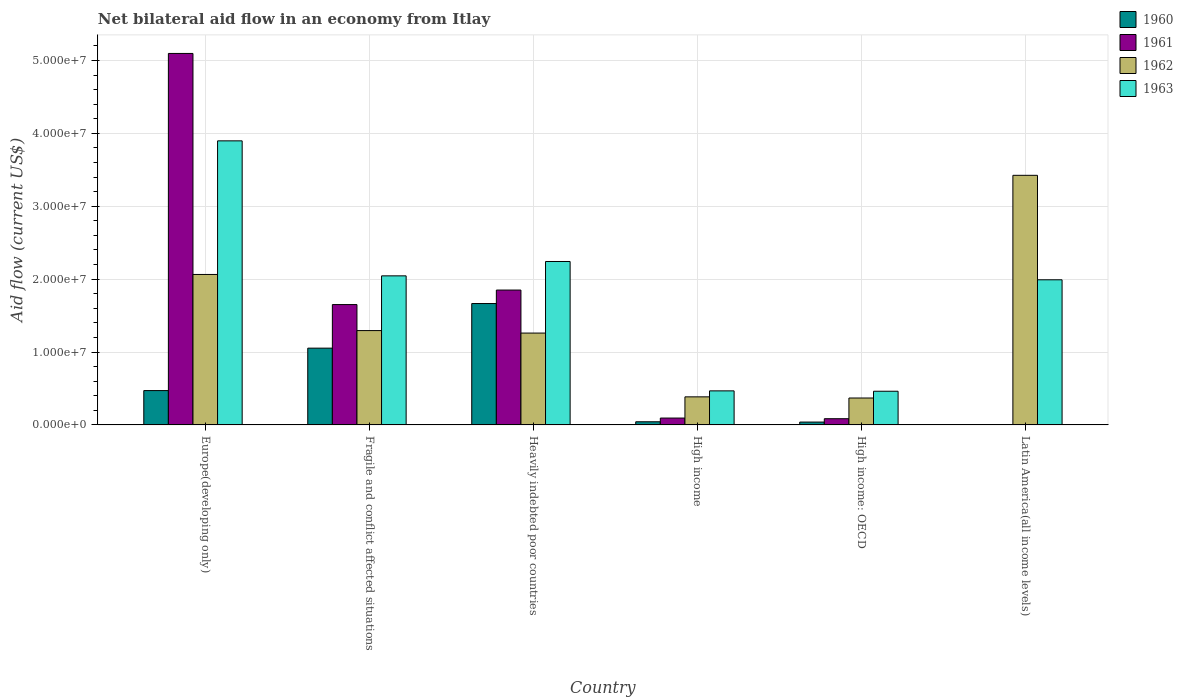How many different coloured bars are there?
Your response must be concise. 4. Are the number of bars on each tick of the X-axis equal?
Your response must be concise. No. How many bars are there on the 4th tick from the right?
Your answer should be compact. 4. What is the label of the 5th group of bars from the left?
Make the answer very short. High income: OECD. In how many cases, is the number of bars for a given country not equal to the number of legend labels?
Offer a terse response. 1. What is the net bilateral aid flow in 1963 in Latin America(all income levels)?
Your answer should be compact. 1.99e+07. Across all countries, what is the maximum net bilateral aid flow in 1962?
Give a very brief answer. 3.42e+07. Across all countries, what is the minimum net bilateral aid flow in 1963?
Provide a succinct answer. 4.62e+06. In which country was the net bilateral aid flow in 1961 maximum?
Offer a very short reply. Europe(developing only). What is the total net bilateral aid flow in 1963 in the graph?
Your response must be concise. 1.11e+08. What is the difference between the net bilateral aid flow in 1960 in Fragile and conflict affected situations and that in High income?
Provide a succinct answer. 1.01e+07. What is the difference between the net bilateral aid flow in 1962 in Europe(developing only) and the net bilateral aid flow in 1961 in Latin America(all income levels)?
Offer a terse response. 2.06e+07. What is the average net bilateral aid flow in 1963 per country?
Offer a very short reply. 1.85e+07. What is the difference between the net bilateral aid flow of/in 1962 and net bilateral aid flow of/in 1963 in Europe(developing only)?
Keep it short and to the point. -1.83e+07. In how many countries, is the net bilateral aid flow in 1962 greater than 14000000 US$?
Offer a very short reply. 2. What is the ratio of the net bilateral aid flow in 1963 in Europe(developing only) to that in Fragile and conflict affected situations?
Offer a terse response. 1.91. What is the difference between the highest and the second highest net bilateral aid flow in 1963?
Your answer should be very brief. 1.66e+07. What is the difference between the highest and the lowest net bilateral aid flow in 1960?
Offer a very short reply. 1.66e+07. Is the sum of the net bilateral aid flow in 1962 in High income and Latin America(all income levels) greater than the maximum net bilateral aid flow in 1961 across all countries?
Your answer should be compact. No. Is it the case that in every country, the sum of the net bilateral aid flow in 1962 and net bilateral aid flow in 1961 is greater than the sum of net bilateral aid flow in 1963 and net bilateral aid flow in 1960?
Offer a terse response. No. Is it the case that in every country, the sum of the net bilateral aid flow in 1961 and net bilateral aid flow in 1963 is greater than the net bilateral aid flow in 1960?
Offer a terse response. Yes. Are all the bars in the graph horizontal?
Your response must be concise. No. Are the values on the major ticks of Y-axis written in scientific E-notation?
Offer a very short reply. Yes. Does the graph contain any zero values?
Keep it short and to the point. Yes. Where does the legend appear in the graph?
Ensure brevity in your answer.  Top right. How many legend labels are there?
Make the answer very short. 4. What is the title of the graph?
Your response must be concise. Net bilateral aid flow in an economy from Itlay. What is the label or title of the Y-axis?
Provide a short and direct response. Aid flow (current US$). What is the Aid flow (current US$) in 1960 in Europe(developing only)?
Offer a very short reply. 4.71e+06. What is the Aid flow (current US$) in 1961 in Europe(developing only)?
Give a very brief answer. 5.10e+07. What is the Aid flow (current US$) of 1962 in Europe(developing only)?
Provide a succinct answer. 2.06e+07. What is the Aid flow (current US$) of 1963 in Europe(developing only)?
Offer a very short reply. 3.90e+07. What is the Aid flow (current US$) of 1960 in Fragile and conflict affected situations?
Make the answer very short. 1.05e+07. What is the Aid flow (current US$) in 1961 in Fragile and conflict affected situations?
Make the answer very short. 1.65e+07. What is the Aid flow (current US$) of 1962 in Fragile and conflict affected situations?
Keep it short and to the point. 1.29e+07. What is the Aid flow (current US$) of 1963 in Fragile and conflict affected situations?
Offer a very short reply. 2.04e+07. What is the Aid flow (current US$) of 1960 in Heavily indebted poor countries?
Provide a short and direct response. 1.66e+07. What is the Aid flow (current US$) of 1961 in Heavily indebted poor countries?
Keep it short and to the point. 1.85e+07. What is the Aid flow (current US$) of 1962 in Heavily indebted poor countries?
Offer a very short reply. 1.26e+07. What is the Aid flow (current US$) of 1963 in Heavily indebted poor countries?
Make the answer very short. 2.24e+07. What is the Aid flow (current US$) of 1961 in High income?
Ensure brevity in your answer.  9.40e+05. What is the Aid flow (current US$) of 1962 in High income?
Your answer should be very brief. 3.85e+06. What is the Aid flow (current US$) in 1963 in High income?
Ensure brevity in your answer.  4.67e+06. What is the Aid flow (current US$) in 1960 in High income: OECD?
Your response must be concise. 3.90e+05. What is the Aid flow (current US$) in 1961 in High income: OECD?
Your response must be concise. 8.50e+05. What is the Aid flow (current US$) in 1962 in High income: OECD?
Offer a very short reply. 3.69e+06. What is the Aid flow (current US$) of 1963 in High income: OECD?
Your answer should be compact. 4.62e+06. What is the Aid flow (current US$) in 1961 in Latin America(all income levels)?
Offer a terse response. 0. What is the Aid flow (current US$) of 1962 in Latin America(all income levels)?
Your answer should be very brief. 3.42e+07. What is the Aid flow (current US$) in 1963 in Latin America(all income levels)?
Provide a succinct answer. 1.99e+07. Across all countries, what is the maximum Aid flow (current US$) in 1960?
Offer a very short reply. 1.66e+07. Across all countries, what is the maximum Aid flow (current US$) in 1961?
Your response must be concise. 5.10e+07. Across all countries, what is the maximum Aid flow (current US$) of 1962?
Your response must be concise. 3.42e+07. Across all countries, what is the maximum Aid flow (current US$) of 1963?
Make the answer very short. 3.90e+07. Across all countries, what is the minimum Aid flow (current US$) of 1961?
Keep it short and to the point. 0. Across all countries, what is the minimum Aid flow (current US$) of 1962?
Keep it short and to the point. 3.69e+06. Across all countries, what is the minimum Aid flow (current US$) in 1963?
Give a very brief answer. 4.62e+06. What is the total Aid flow (current US$) in 1960 in the graph?
Ensure brevity in your answer.  3.27e+07. What is the total Aid flow (current US$) in 1961 in the graph?
Offer a very short reply. 8.78e+07. What is the total Aid flow (current US$) in 1962 in the graph?
Make the answer very short. 8.80e+07. What is the total Aid flow (current US$) of 1963 in the graph?
Offer a terse response. 1.11e+08. What is the difference between the Aid flow (current US$) in 1960 in Europe(developing only) and that in Fragile and conflict affected situations?
Your answer should be very brief. -5.82e+06. What is the difference between the Aid flow (current US$) in 1961 in Europe(developing only) and that in Fragile and conflict affected situations?
Offer a terse response. 3.44e+07. What is the difference between the Aid flow (current US$) in 1962 in Europe(developing only) and that in Fragile and conflict affected situations?
Ensure brevity in your answer.  7.70e+06. What is the difference between the Aid flow (current US$) of 1963 in Europe(developing only) and that in Fragile and conflict affected situations?
Your response must be concise. 1.85e+07. What is the difference between the Aid flow (current US$) of 1960 in Europe(developing only) and that in Heavily indebted poor countries?
Your response must be concise. -1.19e+07. What is the difference between the Aid flow (current US$) of 1961 in Europe(developing only) and that in Heavily indebted poor countries?
Offer a terse response. 3.25e+07. What is the difference between the Aid flow (current US$) of 1962 in Europe(developing only) and that in Heavily indebted poor countries?
Provide a short and direct response. 8.04e+06. What is the difference between the Aid flow (current US$) of 1963 in Europe(developing only) and that in Heavily indebted poor countries?
Your answer should be very brief. 1.66e+07. What is the difference between the Aid flow (current US$) in 1960 in Europe(developing only) and that in High income?
Your answer should be very brief. 4.28e+06. What is the difference between the Aid flow (current US$) of 1961 in Europe(developing only) and that in High income?
Offer a very short reply. 5.00e+07. What is the difference between the Aid flow (current US$) of 1962 in Europe(developing only) and that in High income?
Your answer should be very brief. 1.68e+07. What is the difference between the Aid flow (current US$) of 1963 in Europe(developing only) and that in High income?
Keep it short and to the point. 3.43e+07. What is the difference between the Aid flow (current US$) in 1960 in Europe(developing only) and that in High income: OECD?
Provide a succinct answer. 4.32e+06. What is the difference between the Aid flow (current US$) of 1961 in Europe(developing only) and that in High income: OECD?
Keep it short and to the point. 5.01e+07. What is the difference between the Aid flow (current US$) of 1962 in Europe(developing only) and that in High income: OECD?
Make the answer very short. 1.70e+07. What is the difference between the Aid flow (current US$) in 1963 in Europe(developing only) and that in High income: OECD?
Offer a terse response. 3.44e+07. What is the difference between the Aid flow (current US$) of 1962 in Europe(developing only) and that in Latin America(all income levels)?
Your answer should be compact. -1.36e+07. What is the difference between the Aid flow (current US$) of 1963 in Europe(developing only) and that in Latin America(all income levels)?
Your response must be concise. 1.91e+07. What is the difference between the Aid flow (current US$) of 1960 in Fragile and conflict affected situations and that in Heavily indebted poor countries?
Provide a succinct answer. -6.12e+06. What is the difference between the Aid flow (current US$) in 1961 in Fragile and conflict affected situations and that in Heavily indebted poor countries?
Your response must be concise. -1.99e+06. What is the difference between the Aid flow (current US$) of 1963 in Fragile and conflict affected situations and that in Heavily indebted poor countries?
Your answer should be compact. -1.97e+06. What is the difference between the Aid flow (current US$) in 1960 in Fragile and conflict affected situations and that in High income?
Offer a terse response. 1.01e+07. What is the difference between the Aid flow (current US$) of 1961 in Fragile and conflict affected situations and that in High income?
Your response must be concise. 1.56e+07. What is the difference between the Aid flow (current US$) in 1962 in Fragile and conflict affected situations and that in High income?
Provide a short and direct response. 9.09e+06. What is the difference between the Aid flow (current US$) of 1963 in Fragile and conflict affected situations and that in High income?
Your response must be concise. 1.58e+07. What is the difference between the Aid flow (current US$) of 1960 in Fragile and conflict affected situations and that in High income: OECD?
Make the answer very short. 1.01e+07. What is the difference between the Aid flow (current US$) in 1961 in Fragile and conflict affected situations and that in High income: OECD?
Provide a succinct answer. 1.57e+07. What is the difference between the Aid flow (current US$) in 1962 in Fragile and conflict affected situations and that in High income: OECD?
Ensure brevity in your answer.  9.25e+06. What is the difference between the Aid flow (current US$) in 1963 in Fragile and conflict affected situations and that in High income: OECD?
Offer a very short reply. 1.58e+07. What is the difference between the Aid flow (current US$) of 1962 in Fragile and conflict affected situations and that in Latin America(all income levels)?
Offer a terse response. -2.13e+07. What is the difference between the Aid flow (current US$) in 1963 in Fragile and conflict affected situations and that in Latin America(all income levels)?
Keep it short and to the point. 5.40e+05. What is the difference between the Aid flow (current US$) of 1960 in Heavily indebted poor countries and that in High income?
Ensure brevity in your answer.  1.62e+07. What is the difference between the Aid flow (current US$) in 1961 in Heavily indebted poor countries and that in High income?
Your answer should be very brief. 1.76e+07. What is the difference between the Aid flow (current US$) of 1962 in Heavily indebted poor countries and that in High income?
Keep it short and to the point. 8.75e+06. What is the difference between the Aid flow (current US$) of 1963 in Heavily indebted poor countries and that in High income?
Offer a terse response. 1.78e+07. What is the difference between the Aid flow (current US$) in 1960 in Heavily indebted poor countries and that in High income: OECD?
Your response must be concise. 1.63e+07. What is the difference between the Aid flow (current US$) in 1961 in Heavily indebted poor countries and that in High income: OECD?
Provide a short and direct response. 1.76e+07. What is the difference between the Aid flow (current US$) of 1962 in Heavily indebted poor countries and that in High income: OECD?
Provide a succinct answer. 8.91e+06. What is the difference between the Aid flow (current US$) in 1963 in Heavily indebted poor countries and that in High income: OECD?
Provide a succinct answer. 1.78e+07. What is the difference between the Aid flow (current US$) of 1962 in Heavily indebted poor countries and that in Latin America(all income levels)?
Keep it short and to the point. -2.16e+07. What is the difference between the Aid flow (current US$) in 1963 in Heavily indebted poor countries and that in Latin America(all income levels)?
Provide a succinct answer. 2.51e+06. What is the difference between the Aid flow (current US$) of 1961 in High income and that in High income: OECD?
Your answer should be compact. 9.00e+04. What is the difference between the Aid flow (current US$) of 1962 in High income and that in High income: OECD?
Give a very brief answer. 1.60e+05. What is the difference between the Aid flow (current US$) of 1962 in High income and that in Latin America(all income levels)?
Keep it short and to the point. -3.04e+07. What is the difference between the Aid flow (current US$) of 1963 in High income and that in Latin America(all income levels)?
Keep it short and to the point. -1.52e+07. What is the difference between the Aid flow (current US$) in 1962 in High income: OECD and that in Latin America(all income levels)?
Make the answer very short. -3.06e+07. What is the difference between the Aid flow (current US$) of 1963 in High income: OECD and that in Latin America(all income levels)?
Provide a short and direct response. -1.53e+07. What is the difference between the Aid flow (current US$) of 1960 in Europe(developing only) and the Aid flow (current US$) of 1961 in Fragile and conflict affected situations?
Your answer should be compact. -1.18e+07. What is the difference between the Aid flow (current US$) of 1960 in Europe(developing only) and the Aid flow (current US$) of 1962 in Fragile and conflict affected situations?
Offer a very short reply. -8.23e+06. What is the difference between the Aid flow (current US$) in 1960 in Europe(developing only) and the Aid flow (current US$) in 1963 in Fragile and conflict affected situations?
Make the answer very short. -1.57e+07. What is the difference between the Aid flow (current US$) in 1961 in Europe(developing only) and the Aid flow (current US$) in 1962 in Fragile and conflict affected situations?
Provide a succinct answer. 3.80e+07. What is the difference between the Aid flow (current US$) in 1961 in Europe(developing only) and the Aid flow (current US$) in 1963 in Fragile and conflict affected situations?
Your answer should be compact. 3.05e+07. What is the difference between the Aid flow (current US$) in 1960 in Europe(developing only) and the Aid flow (current US$) in 1961 in Heavily indebted poor countries?
Your answer should be compact. -1.38e+07. What is the difference between the Aid flow (current US$) of 1960 in Europe(developing only) and the Aid flow (current US$) of 1962 in Heavily indebted poor countries?
Your answer should be compact. -7.89e+06. What is the difference between the Aid flow (current US$) in 1960 in Europe(developing only) and the Aid flow (current US$) in 1963 in Heavily indebted poor countries?
Your answer should be compact. -1.77e+07. What is the difference between the Aid flow (current US$) in 1961 in Europe(developing only) and the Aid flow (current US$) in 1962 in Heavily indebted poor countries?
Offer a terse response. 3.84e+07. What is the difference between the Aid flow (current US$) in 1961 in Europe(developing only) and the Aid flow (current US$) in 1963 in Heavily indebted poor countries?
Your answer should be compact. 2.85e+07. What is the difference between the Aid flow (current US$) in 1962 in Europe(developing only) and the Aid flow (current US$) in 1963 in Heavily indebted poor countries?
Your answer should be very brief. -1.78e+06. What is the difference between the Aid flow (current US$) of 1960 in Europe(developing only) and the Aid flow (current US$) of 1961 in High income?
Offer a terse response. 3.77e+06. What is the difference between the Aid flow (current US$) of 1960 in Europe(developing only) and the Aid flow (current US$) of 1962 in High income?
Offer a very short reply. 8.60e+05. What is the difference between the Aid flow (current US$) in 1960 in Europe(developing only) and the Aid flow (current US$) in 1963 in High income?
Keep it short and to the point. 4.00e+04. What is the difference between the Aid flow (current US$) of 1961 in Europe(developing only) and the Aid flow (current US$) of 1962 in High income?
Your answer should be compact. 4.71e+07. What is the difference between the Aid flow (current US$) of 1961 in Europe(developing only) and the Aid flow (current US$) of 1963 in High income?
Provide a succinct answer. 4.63e+07. What is the difference between the Aid flow (current US$) of 1962 in Europe(developing only) and the Aid flow (current US$) of 1963 in High income?
Provide a short and direct response. 1.60e+07. What is the difference between the Aid flow (current US$) of 1960 in Europe(developing only) and the Aid flow (current US$) of 1961 in High income: OECD?
Make the answer very short. 3.86e+06. What is the difference between the Aid flow (current US$) of 1960 in Europe(developing only) and the Aid flow (current US$) of 1962 in High income: OECD?
Your answer should be very brief. 1.02e+06. What is the difference between the Aid flow (current US$) in 1960 in Europe(developing only) and the Aid flow (current US$) in 1963 in High income: OECD?
Make the answer very short. 9.00e+04. What is the difference between the Aid flow (current US$) of 1961 in Europe(developing only) and the Aid flow (current US$) of 1962 in High income: OECD?
Your answer should be very brief. 4.73e+07. What is the difference between the Aid flow (current US$) of 1961 in Europe(developing only) and the Aid flow (current US$) of 1963 in High income: OECD?
Give a very brief answer. 4.63e+07. What is the difference between the Aid flow (current US$) in 1962 in Europe(developing only) and the Aid flow (current US$) in 1963 in High income: OECD?
Your answer should be compact. 1.60e+07. What is the difference between the Aid flow (current US$) in 1960 in Europe(developing only) and the Aid flow (current US$) in 1962 in Latin America(all income levels)?
Make the answer very short. -2.95e+07. What is the difference between the Aid flow (current US$) in 1960 in Europe(developing only) and the Aid flow (current US$) in 1963 in Latin America(all income levels)?
Your response must be concise. -1.52e+07. What is the difference between the Aid flow (current US$) in 1961 in Europe(developing only) and the Aid flow (current US$) in 1962 in Latin America(all income levels)?
Provide a short and direct response. 1.67e+07. What is the difference between the Aid flow (current US$) of 1961 in Europe(developing only) and the Aid flow (current US$) of 1963 in Latin America(all income levels)?
Give a very brief answer. 3.10e+07. What is the difference between the Aid flow (current US$) of 1962 in Europe(developing only) and the Aid flow (current US$) of 1963 in Latin America(all income levels)?
Offer a very short reply. 7.30e+05. What is the difference between the Aid flow (current US$) in 1960 in Fragile and conflict affected situations and the Aid flow (current US$) in 1961 in Heavily indebted poor countries?
Your response must be concise. -7.97e+06. What is the difference between the Aid flow (current US$) in 1960 in Fragile and conflict affected situations and the Aid flow (current US$) in 1962 in Heavily indebted poor countries?
Your response must be concise. -2.07e+06. What is the difference between the Aid flow (current US$) of 1960 in Fragile and conflict affected situations and the Aid flow (current US$) of 1963 in Heavily indebted poor countries?
Make the answer very short. -1.19e+07. What is the difference between the Aid flow (current US$) of 1961 in Fragile and conflict affected situations and the Aid flow (current US$) of 1962 in Heavily indebted poor countries?
Keep it short and to the point. 3.91e+06. What is the difference between the Aid flow (current US$) of 1961 in Fragile and conflict affected situations and the Aid flow (current US$) of 1963 in Heavily indebted poor countries?
Offer a terse response. -5.91e+06. What is the difference between the Aid flow (current US$) in 1962 in Fragile and conflict affected situations and the Aid flow (current US$) in 1963 in Heavily indebted poor countries?
Ensure brevity in your answer.  -9.48e+06. What is the difference between the Aid flow (current US$) in 1960 in Fragile and conflict affected situations and the Aid flow (current US$) in 1961 in High income?
Provide a succinct answer. 9.59e+06. What is the difference between the Aid flow (current US$) in 1960 in Fragile and conflict affected situations and the Aid flow (current US$) in 1962 in High income?
Ensure brevity in your answer.  6.68e+06. What is the difference between the Aid flow (current US$) of 1960 in Fragile and conflict affected situations and the Aid flow (current US$) of 1963 in High income?
Your response must be concise. 5.86e+06. What is the difference between the Aid flow (current US$) of 1961 in Fragile and conflict affected situations and the Aid flow (current US$) of 1962 in High income?
Your answer should be very brief. 1.27e+07. What is the difference between the Aid flow (current US$) in 1961 in Fragile and conflict affected situations and the Aid flow (current US$) in 1963 in High income?
Ensure brevity in your answer.  1.18e+07. What is the difference between the Aid flow (current US$) in 1962 in Fragile and conflict affected situations and the Aid flow (current US$) in 1963 in High income?
Your response must be concise. 8.27e+06. What is the difference between the Aid flow (current US$) of 1960 in Fragile and conflict affected situations and the Aid flow (current US$) of 1961 in High income: OECD?
Ensure brevity in your answer.  9.68e+06. What is the difference between the Aid flow (current US$) in 1960 in Fragile and conflict affected situations and the Aid flow (current US$) in 1962 in High income: OECD?
Provide a succinct answer. 6.84e+06. What is the difference between the Aid flow (current US$) of 1960 in Fragile and conflict affected situations and the Aid flow (current US$) of 1963 in High income: OECD?
Ensure brevity in your answer.  5.91e+06. What is the difference between the Aid flow (current US$) of 1961 in Fragile and conflict affected situations and the Aid flow (current US$) of 1962 in High income: OECD?
Your answer should be very brief. 1.28e+07. What is the difference between the Aid flow (current US$) of 1961 in Fragile and conflict affected situations and the Aid flow (current US$) of 1963 in High income: OECD?
Ensure brevity in your answer.  1.19e+07. What is the difference between the Aid flow (current US$) in 1962 in Fragile and conflict affected situations and the Aid flow (current US$) in 1963 in High income: OECD?
Give a very brief answer. 8.32e+06. What is the difference between the Aid flow (current US$) in 1960 in Fragile and conflict affected situations and the Aid flow (current US$) in 1962 in Latin America(all income levels)?
Your answer should be very brief. -2.37e+07. What is the difference between the Aid flow (current US$) in 1960 in Fragile and conflict affected situations and the Aid flow (current US$) in 1963 in Latin America(all income levels)?
Provide a succinct answer. -9.38e+06. What is the difference between the Aid flow (current US$) in 1961 in Fragile and conflict affected situations and the Aid flow (current US$) in 1962 in Latin America(all income levels)?
Provide a succinct answer. -1.77e+07. What is the difference between the Aid flow (current US$) in 1961 in Fragile and conflict affected situations and the Aid flow (current US$) in 1963 in Latin America(all income levels)?
Your answer should be very brief. -3.40e+06. What is the difference between the Aid flow (current US$) of 1962 in Fragile and conflict affected situations and the Aid flow (current US$) of 1963 in Latin America(all income levels)?
Keep it short and to the point. -6.97e+06. What is the difference between the Aid flow (current US$) of 1960 in Heavily indebted poor countries and the Aid flow (current US$) of 1961 in High income?
Your response must be concise. 1.57e+07. What is the difference between the Aid flow (current US$) in 1960 in Heavily indebted poor countries and the Aid flow (current US$) in 1962 in High income?
Your answer should be compact. 1.28e+07. What is the difference between the Aid flow (current US$) in 1960 in Heavily indebted poor countries and the Aid flow (current US$) in 1963 in High income?
Keep it short and to the point. 1.20e+07. What is the difference between the Aid flow (current US$) in 1961 in Heavily indebted poor countries and the Aid flow (current US$) in 1962 in High income?
Give a very brief answer. 1.46e+07. What is the difference between the Aid flow (current US$) of 1961 in Heavily indebted poor countries and the Aid flow (current US$) of 1963 in High income?
Offer a terse response. 1.38e+07. What is the difference between the Aid flow (current US$) in 1962 in Heavily indebted poor countries and the Aid flow (current US$) in 1963 in High income?
Provide a succinct answer. 7.93e+06. What is the difference between the Aid flow (current US$) in 1960 in Heavily indebted poor countries and the Aid flow (current US$) in 1961 in High income: OECD?
Give a very brief answer. 1.58e+07. What is the difference between the Aid flow (current US$) in 1960 in Heavily indebted poor countries and the Aid flow (current US$) in 1962 in High income: OECD?
Offer a very short reply. 1.30e+07. What is the difference between the Aid flow (current US$) in 1960 in Heavily indebted poor countries and the Aid flow (current US$) in 1963 in High income: OECD?
Your response must be concise. 1.20e+07. What is the difference between the Aid flow (current US$) of 1961 in Heavily indebted poor countries and the Aid flow (current US$) of 1962 in High income: OECD?
Offer a terse response. 1.48e+07. What is the difference between the Aid flow (current US$) of 1961 in Heavily indebted poor countries and the Aid flow (current US$) of 1963 in High income: OECD?
Ensure brevity in your answer.  1.39e+07. What is the difference between the Aid flow (current US$) of 1962 in Heavily indebted poor countries and the Aid flow (current US$) of 1963 in High income: OECD?
Your response must be concise. 7.98e+06. What is the difference between the Aid flow (current US$) of 1960 in Heavily indebted poor countries and the Aid flow (current US$) of 1962 in Latin America(all income levels)?
Your answer should be very brief. -1.76e+07. What is the difference between the Aid flow (current US$) in 1960 in Heavily indebted poor countries and the Aid flow (current US$) in 1963 in Latin America(all income levels)?
Keep it short and to the point. -3.26e+06. What is the difference between the Aid flow (current US$) of 1961 in Heavily indebted poor countries and the Aid flow (current US$) of 1962 in Latin America(all income levels)?
Your answer should be very brief. -1.57e+07. What is the difference between the Aid flow (current US$) of 1961 in Heavily indebted poor countries and the Aid flow (current US$) of 1963 in Latin America(all income levels)?
Provide a short and direct response. -1.41e+06. What is the difference between the Aid flow (current US$) in 1962 in Heavily indebted poor countries and the Aid flow (current US$) in 1963 in Latin America(all income levels)?
Offer a terse response. -7.31e+06. What is the difference between the Aid flow (current US$) of 1960 in High income and the Aid flow (current US$) of 1961 in High income: OECD?
Give a very brief answer. -4.20e+05. What is the difference between the Aid flow (current US$) of 1960 in High income and the Aid flow (current US$) of 1962 in High income: OECD?
Your answer should be compact. -3.26e+06. What is the difference between the Aid flow (current US$) of 1960 in High income and the Aid flow (current US$) of 1963 in High income: OECD?
Ensure brevity in your answer.  -4.19e+06. What is the difference between the Aid flow (current US$) in 1961 in High income and the Aid flow (current US$) in 1962 in High income: OECD?
Give a very brief answer. -2.75e+06. What is the difference between the Aid flow (current US$) in 1961 in High income and the Aid flow (current US$) in 1963 in High income: OECD?
Give a very brief answer. -3.68e+06. What is the difference between the Aid flow (current US$) of 1962 in High income and the Aid flow (current US$) of 1963 in High income: OECD?
Your response must be concise. -7.70e+05. What is the difference between the Aid flow (current US$) in 1960 in High income and the Aid flow (current US$) in 1962 in Latin America(all income levels)?
Provide a short and direct response. -3.38e+07. What is the difference between the Aid flow (current US$) of 1960 in High income and the Aid flow (current US$) of 1963 in Latin America(all income levels)?
Your answer should be very brief. -1.95e+07. What is the difference between the Aid flow (current US$) in 1961 in High income and the Aid flow (current US$) in 1962 in Latin America(all income levels)?
Keep it short and to the point. -3.33e+07. What is the difference between the Aid flow (current US$) in 1961 in High income and the Aid flow (current US$) in 1963 in Latin America(all income levels)?
Give a very brief answer. -1.90e+07. What is the difference between the Aid flow (current US$) in 1962 in High income and the Aid flow (current US$) in 1963 in Latin America(all income levels)?
Offer a very short reply. -1.61e+07. What is the difference between the Aid flow (current US$) of 1960 in High income: OECD and the Aid flow (current US$) of 1962 in Latin America(all income levels)?
Offer a terse response. -3.38e+07. What is the difference between the Aid flow (current US$) in 1960 in High income: OECD and the Aid flow (current US$) in 1963 in Latin America(all income levels)?
Provide a short and direct response. -1.95e+07. What is the difference between the Aid flow (current US$) of 1961 in High income: OECD and the Aid flow (current US$) of 1962 in Latin America(all income levels)?
Provide a succinct answer. -3.34e+07. What is the difference between the Aid flow (current US$) of 1961 in High income: OECD and the Aid flow (current US$) of 1963 in Latin America(all income levels)?
Your answer should be very brief. -1.91e+07. What is the difference between the Aid flow (current US$) in 1962 in High income: OECD and the Aid flow (current US$) in 1963 in Latin America(all income levels)?
Offer a very short reply. -1.62e+07. What is the average Aid flow (current US$) of 1960 per country?
Give a very brief answer. 5.45e+06. What is the average Aid flow (current US$) in 1961 per country?
Your answer should be compact. 1.46e+07. What is the average Aid flow (current US$) of 1962 per country?
Your answer should be compact. 1.47e+07. What is the average Aid flow (current US$) of 1963 per country?
Your answer should be very brief. 1.85e+07. What is the difference between the Aid flow (current US$) of 1960 and Aid flow (current US$) of 1961 in Europe(developing only)?
Your response must be concise. -4.62e+07. What is the difference between the Aid flow (current US$) in 1960 and Aid flow (current US$) in 1962 in Europe(developing only)?
Your answer should be very brief. -1.59e+07. What is the difference between the Aid flow (current US$) in 1960 and Aid flow (current US$) in 1963 in Europe(developing only)?
Make the answer very short. -3.43e+07. What is the difference between the Aid flow (current US$) of 1961 and Aid flow (current US$) of 1962 in Europe(developing only)?
Give a very brief answer. 3.03e+07. What is the difference between the Aid flow (current US$) in 1961 and Aid flow (current US$) in 1963 in Europe(developing only)?
Your response must be concise. 1.20e+07. What is the difference between the Aid flow (current US$) in 1962 and Aid flow (current US$) in 1963 in Europe(developing only)?
Make the answer very short. -1.83e+07. What is the difference between the Aid flow (current US$) of 1960 and Aid flow (current US$) of 1961 in Fragile and conflict affected situations?
Offer a terse response. -5.98e+06. What is the difference between the Aid flow (current US$) in 1960 and Aid flow (current US$) in 1962 in Fragile and conflict affected situations?
Make the answer very short. -2.41e+06. What is the difference between the Aid flow (current US$) of 1960 and Aid flow (current US$) of 1963 in Fragile and conflict affected situations?
Your answer should be compact. -9.92e+06. What is the difference between the Aid flow (current US$) in 1961 and Aid flow (current US$) in 1962 in Fragile and conflict affected situations?
Give a very brief answer. 3.57e+06. What is the difference between the Aid flow (current US$) of 1961 and Aid flow (current US$) of 1963 in Fragile and conflict affected situations?
Offer a very short reply. -3.94e+06. What is the difference between the Aid flow (current US$) in 1962 and Aid flow (current US$) in 1963 in Fragile and conflict affected situations?
Ensure brevity in your answer.  -7.51e+06. What is the difference between the Aid flow (current US$) of 1960 and Aid flow (current US$) of 1961 in Heavily indebted poor countries?
Offer a terse response. -1.85e+06. What is the difference between the Aid flow (current US$) of 1960 and Aid flow (current US$) of 1962 in Heavily indebted poor countries?
Provide a succinct answer. 4.05e+06. What is the difference between the Aid flow (current US$) in 1960 and Aid flow (current US$) in 1963 in Heavily indebted poor countries?
Your answer should be compact. -5.77e+06. What is the difference between the Aid flow (current US$) in 1961 and Aid flow (current US$) in 1962 in Heavily indebted poor countries?
Make the answer very short. 5.90e+06. What is the difference between the Aid flow (current US$) in 1961 and Aid flow (current US$) in 1963 in Heavily indebted poor countries?
Keep it short and to the point. -3.92e+06. What is the difference between the Aid flow (current US$) in 1962 and Aid flow (current US$) in 1963 in Heavily indebted poor countries?
Ensure brevity in your answer.  -9.82e+06. What is the difference between the Aid flow (current US$) in 1960 and Aid flow (current US$) in 1961 in High income?
Provide a short and direct response. -5.10e+05. What is the difference between the Aid flow (current US$) in 1960 and Aid flow (current US$) in 1962 in High income?
Make the answer very short. -3.42e+06. What is the difference between the Aid flow (current US$) in 1960 and Aid flow (current US$) in 1963 in High income?
Your answer should be compact. -4.24e+06. What is the difference between the Aid flow (current US$) in 1961 and Aid flow (current US$) in 1962 in High income?
Ensure brevity in your answer.  -2.91e+06. What is the difference between the Aid flow (current US$) of 1961 and Aid flow (current US$) of 1963 in High income?
Your response must be concise. -3.73e+06. What is the difference between the Aid flow (current US$) of 1962 and Aid flow (current US$) of 1963 in High income?
Your answer should be compact. -8.20e+05. What is the difference between the Aid flow (current US$) of 1960 and Aid flow (current US$) of 1961 in High income: OECD?
Your answer should be compact. -4.60e+05. What is the difference between the Aid flow (current US$) of 1960 and Aid flow (current US$) of 1962 in High income: OECD?
Offer a very short reply. -3.30e+06. What is the difference between the Aid flow (current US$) of 1960 and Aid flow (current US$) of 1963 in High income: OECD?
Offer a terse response. -4.23e+06. What is the difference between the Aid flow (current US$) of 1961 and Aid flow (current US$) of 1962 in High income: OECD?
Provide a succinct answer. -2.84e+06. What is the difference between the Aid flow (current US$) of 1961 and Aid flow (current US$) of 1963 in High income: OECD?
Offer a terse response. -3.77e+06. What is the difference between the Aid flow (current US$) of 1962 and Aid flow (current US$) of 1963 in High income: OECD?
Provide a short and direct response. -9.30e+05. What is the difference between the Aid flow (current US$) in 1962 and Aid flow (current US$) in 1963 in Latin America(all income levels)?
Give a very brief answer. 1.43e+07. What is the ratio of the Aid flow (current US$) of 1960 in Europe(developing only) to that in Fragile and conflict affected situations?
Ensure brevity in your answer.  0.45. What is the ratio of the Aid flow (current US$) in 1961 in Europe(developing only) to that in Fragile and conflict affected situations?
Provide a short and direct response. 3.09. What is the ratio of the Aid flow (current US$) in 1962 in Europe(developing only) to that in Fragile and conflict affected situations?
Make the answer very short. 1.6. What is the ratio of the Aid flow (current US$) of 1963 in Europe(developing only) to that in Fragile and conflict affected situations?
Make the answer very short. 1.91. What is the ratio of the Aid flow (current US$) of 1960 in Europe(developing only) to that in Heavily indebted poor countries?
Your answer should be compact. 0.28. What is the ratio of the Aid flow (current US$) in 1961 in Europe(developing only) to that in Heavily indebted poor countries?
Offer a terse response. 2.75. What is the ratio of the Aid flow (current US$) in 1962 in Europe(developing only) to that in Heavily indebted poor countries?
Keep it short and to the point. 1.64. What is the ratio of the Aid flow (current US$) in 1963 in Europe(developing only) to that in Heavily indebted poor countries?
Provide a short and direct response. 1.74. What is the ratio of the Aid flow (current US$) in 1960 in Europe(developing only) to that in High income?
Keep it short and to the point. 10.95. What is the ratio of the Aid flow (current US$) of 1961 in Europe(developing only) to that in High income?
Offer a very short reply. 54.21. What is the ratio of the Aid flow (current US$) in 1962 in Europe(developing only) to that in High income?
Give a very brief answer. 5.36. What is the ratio of the Aid flow (current US$) in 1963 in Europe(developing only) to that in High income?
Provide a short and direct response. 8.34. What is the ratio of the Aid flow (current US$) in 1960 in Europe(developing only) to that in High income: OECD?
Your response must be concise. 12.08. What is the ratio of the Aid flow (current US$) in 1961 in Europe(developing only) to that in High income: OECD?
Give a very brief answer. 59.95. What is the ratio of the Aid flow (current US$) in 1962 in Europe(developing only) to that in High income: OECD?
Your response must be concise. 5.59. What is the ratio of the Aid flow (current US$) in 1963 in Europe(developing only) to that in High income: OECD?
Provide a succinct answer. 8.44. What is the ratio of the Aid flow (current US$) of 1962 in Europe(developing only) to that in Latin America(all income levels)?
Give a very brief answer. 0.6. What is the ratio of the Aid flow (current US$) of 1963 in Europe(developing only) to that in Latin America(all income levels)?
Ensure brevity in your answer.  1.96. What is the ratio of the Aid flow (current US$) of 1960 in Fragile and conflict affected situations to that in Heavily indebted poor countries?
Provide a succinct answer. 0.63. What is the ratio of the Aid flow (current US$) of 1961 in Fragile and conflict affected situations to that in Heavily indebted poor countries?
Your answer should be very brief. 0.89. What is the ratio of the Aid flow (current US$) in 1963 in Fragile and conflict affected situations to that in Heavily indebted poor countries?
Your answer should be very brief. 0.91. What is the ratio of the Aid flow (current US$) of 1960 in Fragile and conflict affected situations to that in High income?
Your response must be concise. 24.49. What is the ratio of the Aid flow (current US$) in 1961 in Fragile and conflict affected situations to that in High income?
Provide a succinct answer. 17.56. What is the ratio of the Aid flow (current US$) in 1962 in Fragile and conflict affected situations to that in High income?
Give a very brief answer. 3.36. What is the ratio of the Aid flow (current US$) in 1963 in Fragile and conflict affected situations to that in High income?
Make the answer very short. 4.38. What is the ratio of the Aid flow (current US$) in 1961 in Fragile and conflict affected situations to that in High income: OECD?
Offer a very short reply. 19.42. What is the ratio of the Aid flow (current US$) in 1962 in Fragile and conflict affected situations to that in High income: OECD?
Your answer should be compact. 3.51. What is the ratio of the Aid flow (current US$) in 1963 in Fragile and conflict affected situations to that in High income: OECD?
Keep it short and to the point. 4.43. What is the ratio of the Aid flow (current US$) of 1962 in Fragile and conflict affected situations to that in Latin America(all income levels)?
Offer a terse response. 0.38. What is the ratio of the Aid flow (current US$) in 1963 in Fragile and conflict affected situations to that in Latin America(all income levels)?
Give a very brief answer. 1.03. What is the ratio of the Aid flow (current US$) in 1960 in Heavily indebted poor countries to that in High income?
Your answer should be very brief. 38.72. What is the ratio of the Aid flow (current US$) of 1961 in Heavily indebted poor countries to that in High income?
Make the answer very short. 19.68. What is the ratio of the Aid flow (current US$) of 1962 in Heavily indebted poor countries to that in High income?
Give a very brief answer. 3.27. What is the ratio of the Aid flow (current US$) of 1963 in Heavily indebted poor countries to that in High income?
Give a very brief answer. 4.8. What is the ratio of the Aid flow (current US$) in 1960 in Heavily indebted poor countries to that in High income: OECD?
Keep it short and to the point. 42.69. What is the ratio of the Aid flow (current US$) in 1961 in Heavily indebted poor countries to that in High income: OECD?
Give a very brief answer. 21.76. What is the ratio of the Aid flow (current US$) in 1962 in Heavily indebted poor countries to that in High income: OECD?
Give a very brief answer. 3.41. What is the ratio of the Aid flow (current US$) in 1963 in Heavily indebted poor countries to that in High income: OECD?
Provide a succinct answer. 4.85. What is the ratio of the Aid flow (current US$) of 1962 in Heavily indebted poor countries to that in Latin America(all income levels)?
Ensure brevity in your answer.  0.37. What is the ratio of the Aid flow (current US$) in 1963 in Heavily indebted poor countries to that in Latin America(all income levels)?
Keep it short and to the point. 1.13. What is the ratio of the Aid flow (current US$) of 1960 in High income to that in High income: OECD?
Your answer should be very brief. 1.1. What is the ratio of the Aid flow (current US$) in 1961 in High income to that in High income: OECD?
Your answer should be very brief. 1.11. What is the ratio of the Aid flow (current US$) of 1962 in High income to that in High income: OECD?
Keep it short and to the point. 1.04. What is the ratio of the Aid flow (current US$) of 1963 in High income to that in High income: OECD?
Offer a terse response. 1.01. What is the ratio of the Aid flow (current US$) of 1962 in High income to that in Latin America(all income levels)?
Your answer should be very brief. 0.11. What is the ratio of the Aid flow (current US$) in 1963 in High income to that in Latin America(all income levels)?
Your answer should be very brief. 0.23. What is the ratio of the Aid flow (current US$) in 1962 in High income: OECD to that in Latin America(all income levels)?
Your response must be concise. 0.11. What is the ratio of the Aid flow (current US$) of 1963 in High income: OECD to that in Latin America(all income levels)?
Your response must be concise. 0.23. What is the difference between the highest and the second highest Aid flow (current US$) of 1960?
Provide a succinct answer. 6.12e+06. What is the difference between the highest and the second highest Aid flow (current US$) of 1961?
Provide a succinct answer. 3.25e+07. What is the difference between the highest and the second highest Aid flow (current US$) in 1962?
Your answer should be very brief. 1.36e+07. What is the difference between the highest and the second highest Aid flow (current US$) of 1963?
Keep it short and to the point. 1.66e+07. What is the difference between the highest and the lowest Aid flow (current US$) of 1960?
Your response must be concise. 1.66e+07. What is the difference between the highest and the lowest Aid flow (current US$) in 1961?
Your answer should be compact. 5.10e+07. What is the difference between the highest and the lowest Aid flow (current US$) of 1962?
Provide a short and direct response. 3.06e+07. What is the difference between the highest and the lowest Aid flow (current US$) of 1963?
Provide a short and direct response. 3.44e+07. 